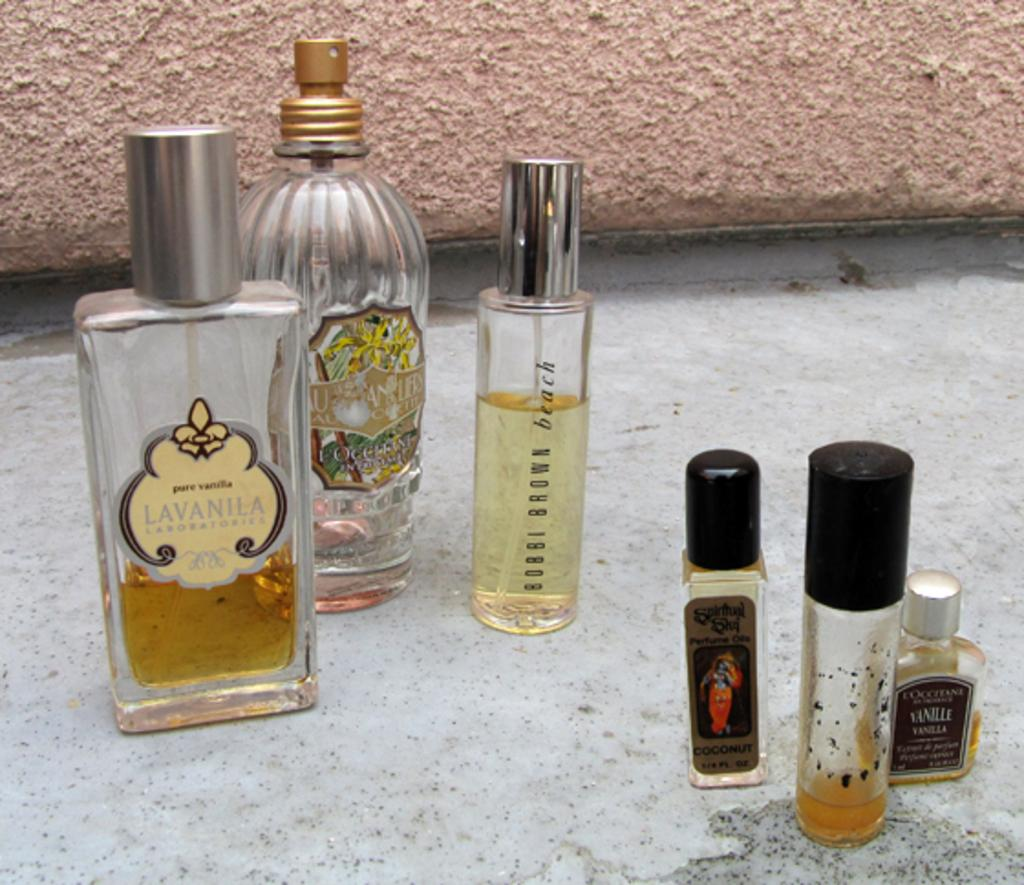<image>
Write a terse but informative summary of the picture. A half empty bottle of Lavanila sitting on a table. 